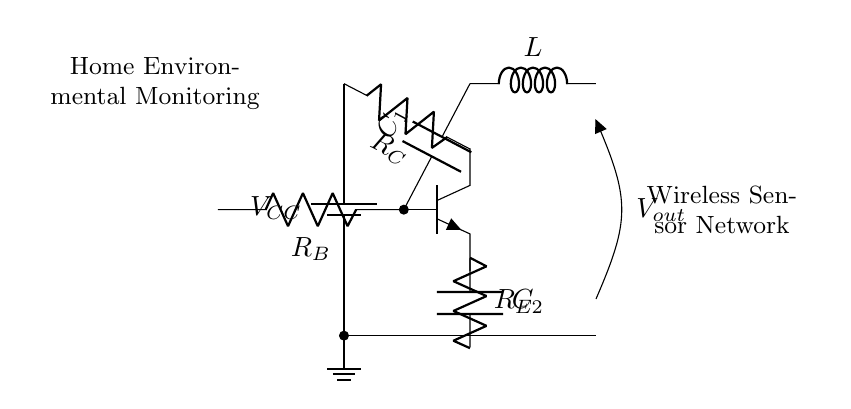What type of oscillator is shown in the circuit? The circuit is a Colpitts oscillator, which typically uses a combination of capacitors and an inductor to generate oscillations. The presence of capacitive voltage division indicates it's a Colpitts configuration.
Answer: Colpitts oscillator What is the role of the inductor in this circuit? The inductor is part of the tank circuit, which works with the capacitors to establish the oscillation frequency. It stores energy in the magnetic field and helps control the oscillation behavior of the circuit.
Answer: Frequency control What do the resistors in the circuit do? The resistors provide biasing and prevent excessive current through the transistor, ensuring the device operates within its safe limits. They work together to promote stable operation of the oscillator.
Answer: Biasing What is the output voltage labeled as in the circuit? The output voltage is labeled Vout, indicating the signal produced by the oscillator circuit that can be used for further processing or transmission in the wireless sensor network.
Answer: Vout How does C1 affect the transistor's operation? C1 is connected to the base of the transistor and influences its switching behavior. By coupling the AC signal to the base, it helps to set the oscillation conditions and defines the frequency and amplitude of the oscillation.
Answer: Sets oscillation conditions Why is this oscillator circuit suitable for wireless sensor networks? The oscillator generates a stable radio frequency signal, which is essential for transmitting data wirelessly. Its design allows it to be efficient and compact, making it ideal for applications like environmental monitoring.
Answer: Suitable for RF transmission 